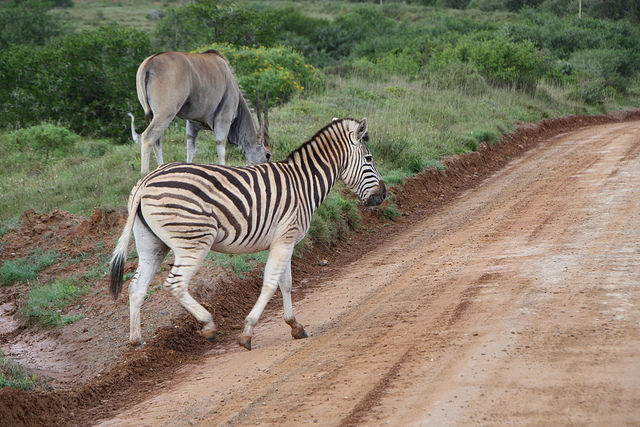What is the zebra on the left about to step into?
A. hay
B. grass
C. road
D. water The zebra appears to be on a dirt path, which is neither a paved road common in urban settings nor a body of water. The options 'hay' and 'grass' also don't accurately describe the surfaced trail made primarily of dirt and clay, typical in natural reserves or parks. So while none of the options presented in the original question perfectly match the image, 'C. road' could be considered the closest answer, as it refers to a general path for travelling. However, a more precise term for the zebra's immediate surroundings would be 'dirt path' or 'trail'. 